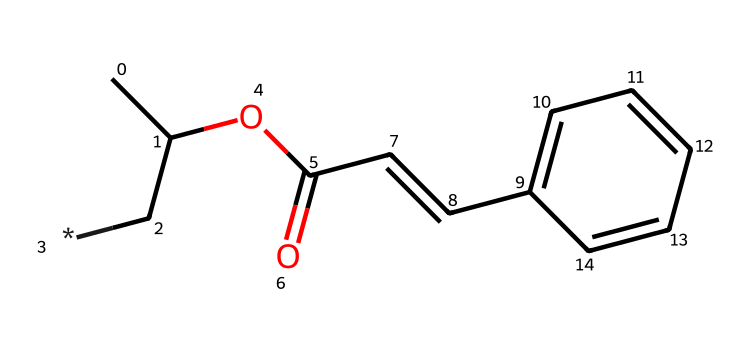What is the name of the chemical represented by this SMILES? The SMILES notation "CC(C[*])OC(=O)C=Cc1ccccc1" corresponds to polyvinyl cinnamate, which has a structured representation often used in the field of materials science and electronics.
Answer: polyvinyl cinnamate How many carbon atoms are present in the chemical? Upon inspecting the structure from the SMILES, there are 12 carbon atoms in total. This includes the ones contributing to the side chains and the aromatic ring system.
Answer: 12 What functional groups can be identified in this photoresist? The structure contains an ester group (indicated by “OC(=O)”) and a vinyl group (indicated by “C=C”). These groups are characteristic for photoresists as they affect the polymerization process upon exposure to light.
Answer: ester, vinyl What type of photoresist is polyvinyl cinnamate classified as? Polyvinyl cinnamate is classified as a negative photoresist, meaning that upon exposure to light, the areas that are exposed become insoluble, as opposed to positive resists where exposed areas remain soluble.
Answer: negative What is a key property of polyvinyl cinnamate when exposed to UV light? The key property is crosslinking, which occurs when the molecule undergoes a chemical change in response to UV light, making the exposed areas less soluble and thus forming a stable pattern suitable for circuit board manufacturing.
Answer: crosslinking Which part of the molecule is primarily responsible for its photoresponsive behavior? The vinyl group (C=C) in the structure is primarily responsible for its photoresponsive behavior because it allows for the polymerization process triggered by UV light exposure.
Answer: vinyl group 